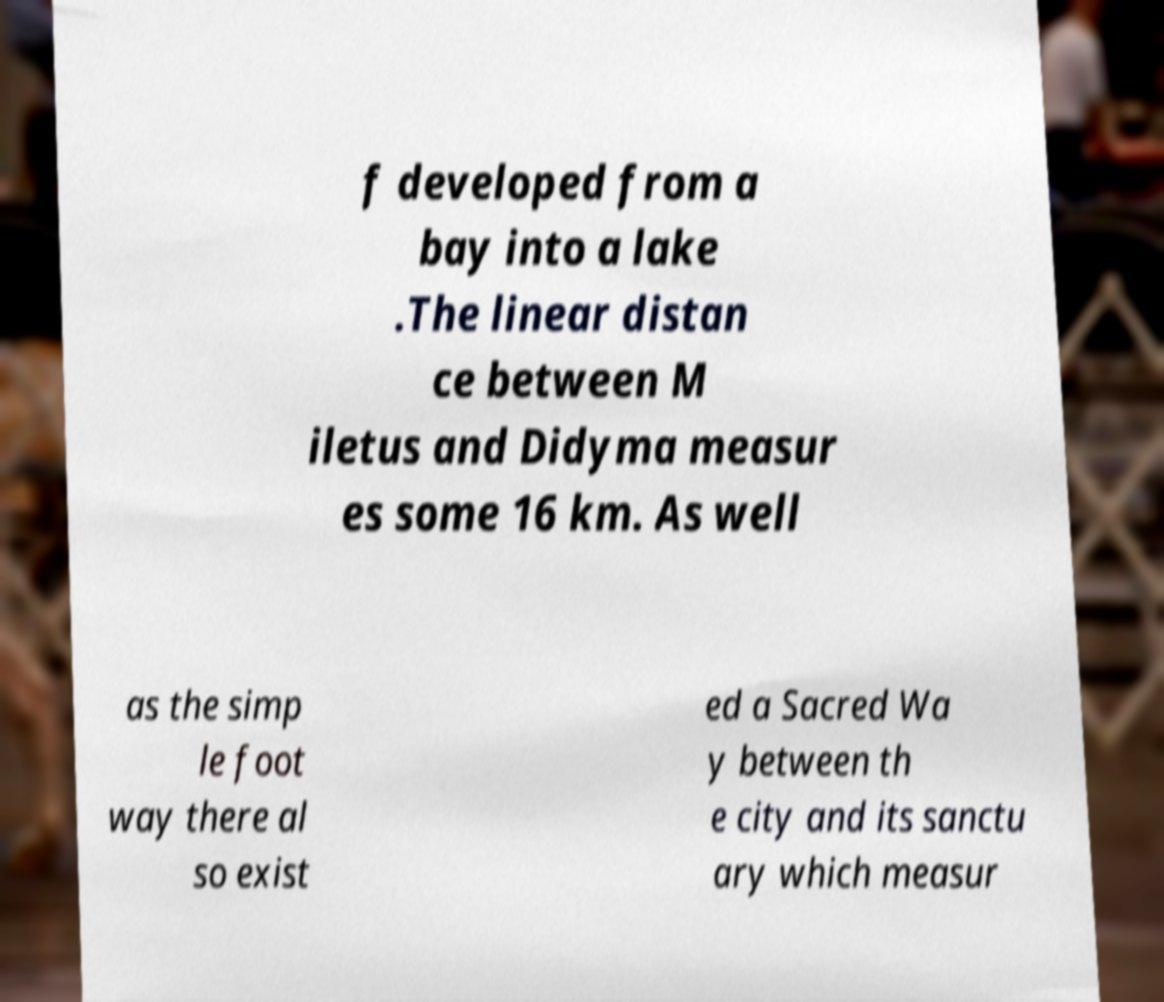For documentation purposes, I need the text within this image transcribed. Could you provide that? f developed from a bay into a lake .The linear distan ce between M iletus and Didyma measur es some 16 km. As well as the simp le foot way there al so exist ed a Sacred Wa y between th e city and its sanctu ary which measur 